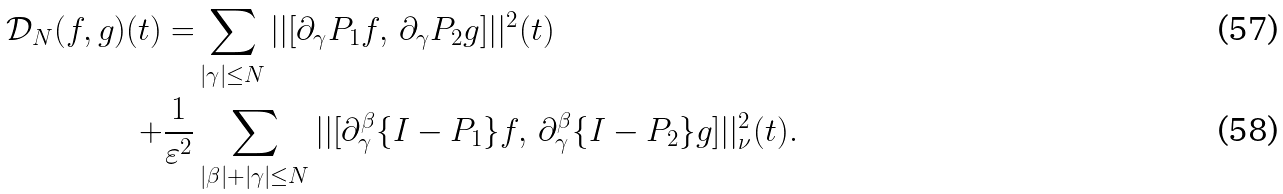<formula> <loc_0><loc_0><loc_500><loc_500>\mathcal { D } _ { N } ( f , g ) ( t ) = & \sum _ { | \gamma | \leq N } | | [ \partial _ { \gamma } P _ { 1 } f , \, \partial _ { \gamma } P _ { 2 } g ] | | ^ { 2 } ( t ) \\ + \frac { 1 } { \varepsilon ^ { 2 } } & \sum _ { | \beta | + | \gamma | \leq N } | | [ \partial _ { \gamma } ^ { \beta } \{ I - P _ { 1 } \} f , \, \partial _ { \gamma } ^ { \beta } \{ I - P _ { 2 } \} g ] | | _ { \nu } ^ { 2 } ( t ) .</formula> 